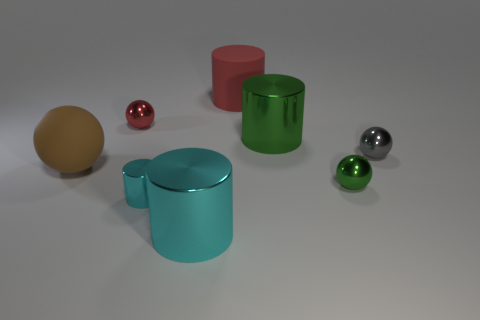Is the number of gray balls less than the number of large brown matte cubes?
Provide a short and direct response. No. What color is the matte object that is left of the big metallic object left of the red cylinder?
Make the answer very short. Brown. What material is the large green object that is the same shape as the large red thing?
Ensure brevity in your answer.  Metal. What number of rubber objects are either brown blocks or large brown objects?
Your response must be concise. 1. Does the big cylinder that is in front of the green metallic cylinder have the same material as the large thing that is on the right side of the red rubber cylinder?
Keep it short and to the point. Yes. Are any tiny purple matte things visible?
Keep it short and to the point. No. Does the rubber thing right of the large brown rubber thing have the same shape as the large metal object in front of the brown matte ball?
Provide a succinct answer. Yes. Are there any large red things made of the same material as the large brown thing?
Keep it short and to the point. Yes. Is the red object on the left side of the large cyan object made of the same material as the red cylinder?
Make the answer very short. No. Is the number of large things behind the gray metal ball greater than the number of cylinders left of the green cylinder?
Your answer should be compact. No. 